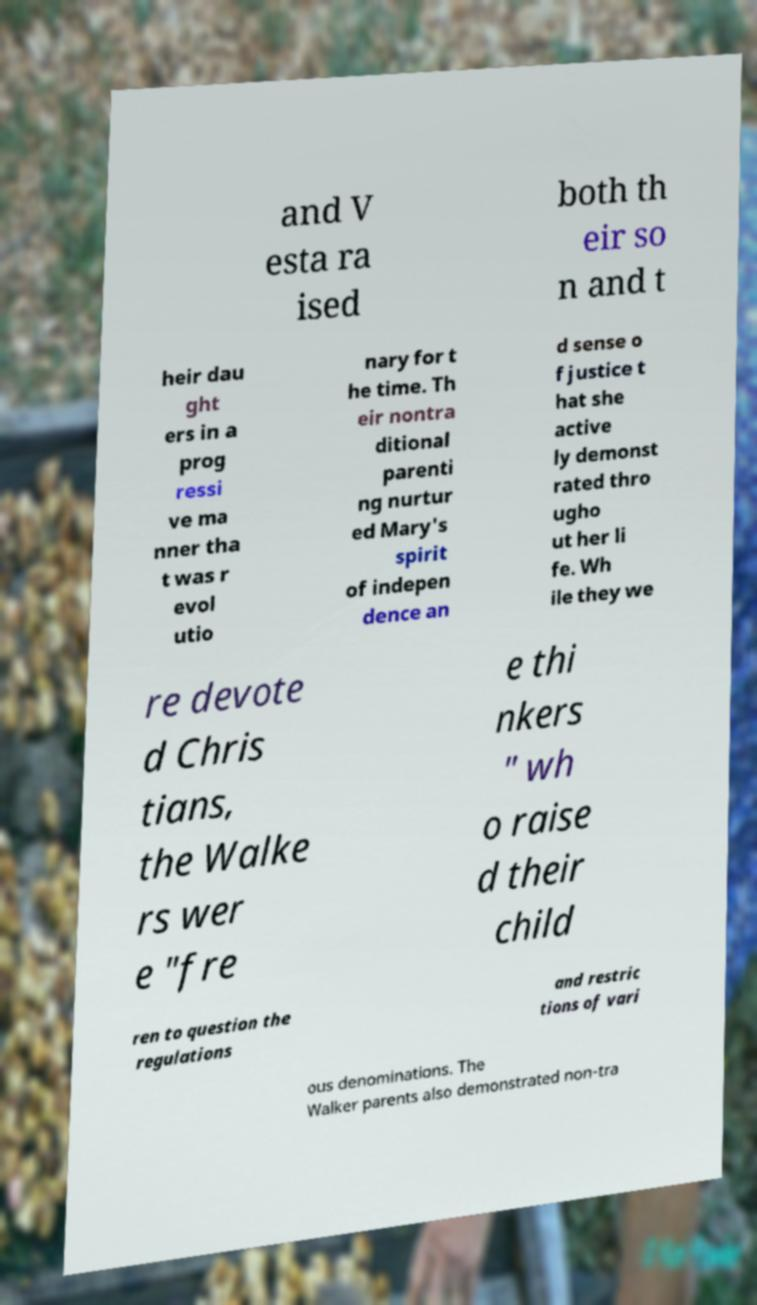Could you assist in decoding the text presented in this image and type it out clearly? and V esta ra ised both th eir so n and t heir dau ght ers in a prog ressi ve ma nner tha t was r evol utio nary for t he time. Th eir nontra ditional parenti ng nurtur ed Mary's spirit of indepen dence an d sense o f justice t hat she active ly demonst rated thro ugho ut her li fe. Wh ile they we re devote d Chris tians, the Walke rs wer e "fre e thi nkers " wh o raise d their child ren to question the regulations and restric tions of vari ous denominations. The Walker parents also demonstrated non-tra 